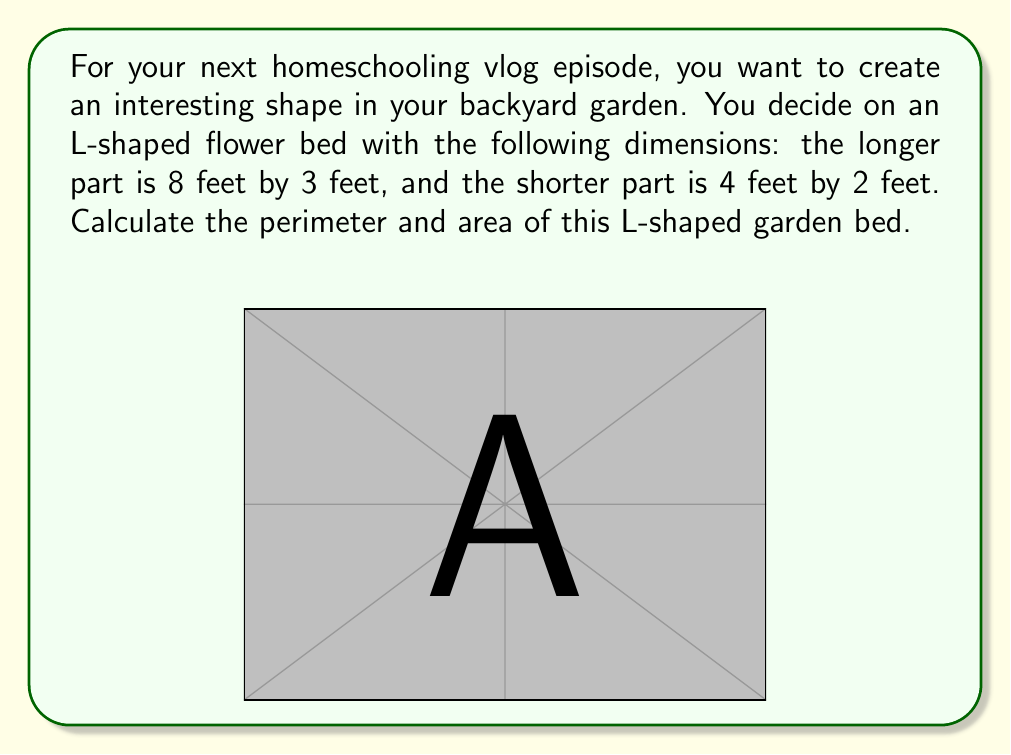Show me your answer to this math problem. Let's approach this step-by-step:

1) First, let's calculate the perimeter:
   - To find the perimeter, we need to add up all the outer edges of the shape.
   - Starting from the top-left corner and going clockwise:
     $$ 4 + 2 + 4 + 3 + 8 + 5 = 26 \text{ feet} $$

2) Now, let's calculate the area:
   - We can divide this L-shape into two rectangles.
   - Rectangle 1 (longer part): $8 \text{ ft} \times 3 \text{ ft} = 24 \text{ sq ft}$
   - Rectangle 2 (shorter part): $4 \text{ ft} \times 2 \text{ ft} = 8 \text{ sq ft}$
   - Total area: $24 \text{ sq ft} + 8 \text{ sq ft} = 32 \text{ sq ft}$

Therefore, the perimeter of the L-shaped garden bed is 26 feet, and its area is 32 square feet.
Answer: Perimeter: 26 ft; Area: 32 sq ft 